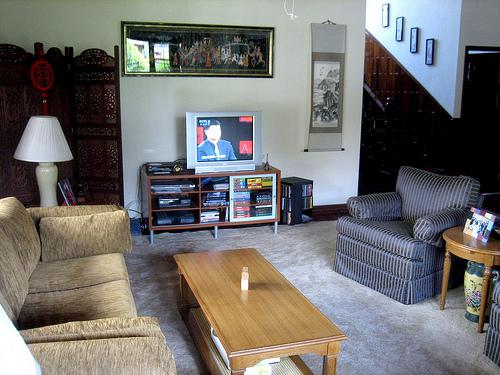Question: where was this photo taken?
Choices:
A. In a living room.
B. In the den.
C. In the family room.
D. In the dining room.
Answer with the letter. Answer: A Question: what color is the lamp?
Choices:
A. Orange.
B. Yellow.
C. Green.
D. White.
Answer with the letter. Answer: D Question: when was this photo taken?
Choices:
A. Night.
B. Daytime.
C. Sunset.
D. Sunrise.
Answer with the letter. Answer: B 